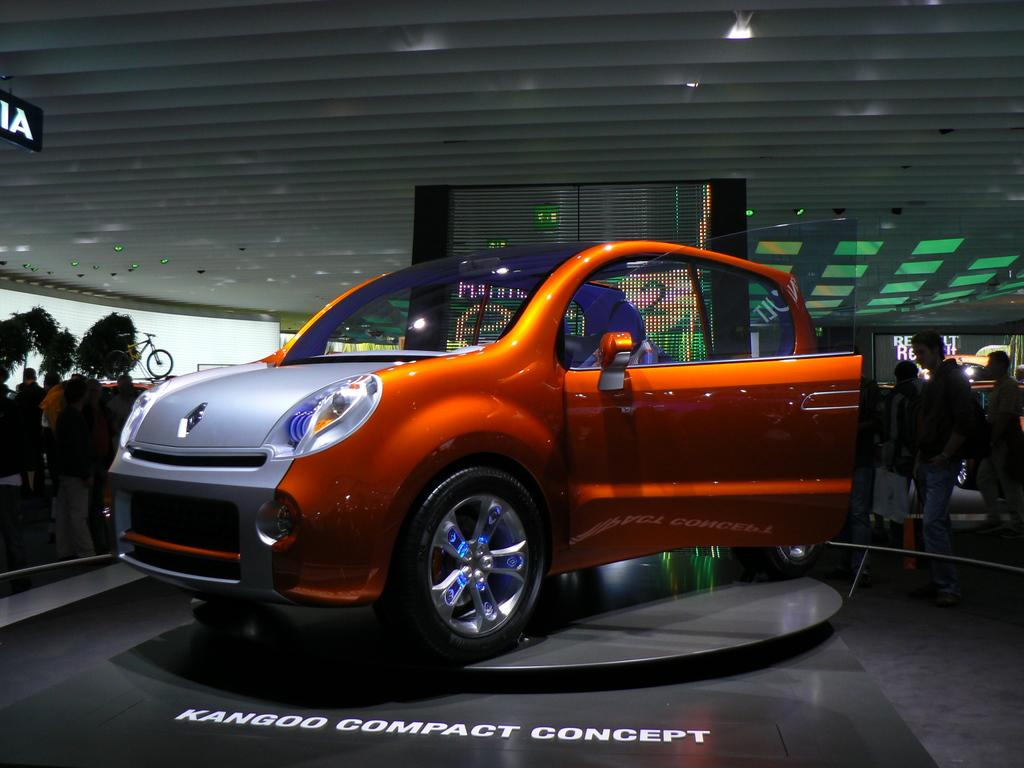What is the main subject of the image? There is a car in the image. What else can be seen in the background of the image? There are people and lights visible in the background of the image. Are there any other vehicles present in the image? Yes, there is a bicycle in the image. What type of square object can be seen on the car in the image? There is no square object visible on the car in the image. What kind of cap is the beetle wearing in the image? There is no beetle or cap present in the image. 